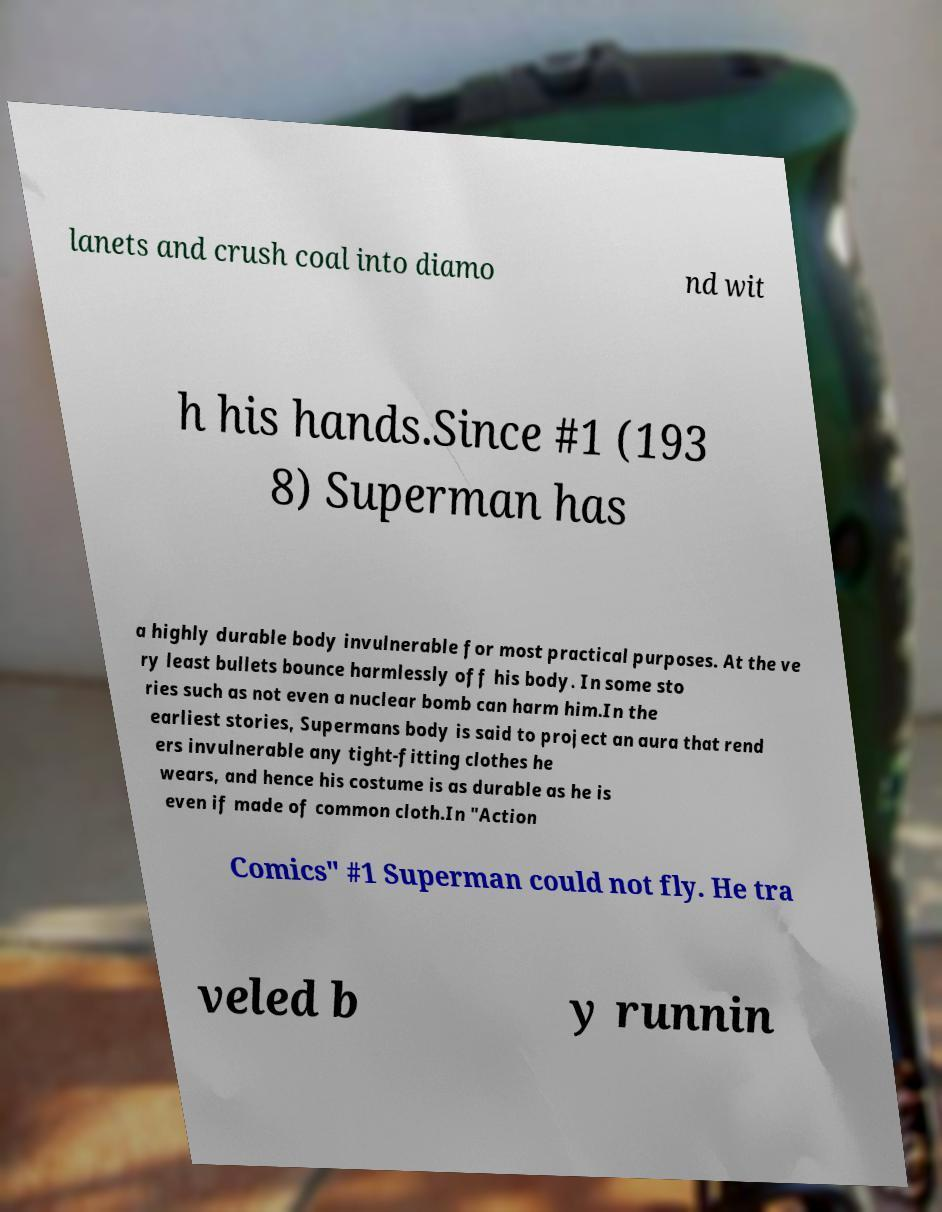Could you assist in decoding the text presented in this image and type it out clearly? lanets and crush coal into diamo nd wit h his hands.Since #1 (193 8) Superman has a highly durable body invulnerable for most practical purposes. At the ve ry least bullets bounce harmlessly off his body. In some sto ries such as not even a nuclear bomb can harm him.In the earliest stories, Supermans body is said to project an aura that rend ers invulnerable any tight-fitting clothes he wears, and hence his costume is as durable as he is even if made of common cloth.In "Action Comics" #1 Superman could not fly. He tra veled b y runnin 